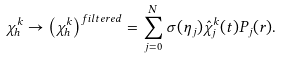Convert formula to latex. <formula><loc_0><loc_0><loc_500><loc_500>\chi ^ { k } _ { h } \rightarrow \left ( \chi ^ { k } _ { h } \right ) ^ { f i l t e r e d } = \sum _ { j = 0 } ^ { N } \sigma ( \eta _ { j } ) \hat { \chi } ^ { k } _ { j } ( t ) P _ { j } ( r ) .</formula> 